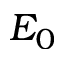Convert formula to latex. <formula><loc_0><loc_0><loc_500><loc_500>E _ { 0 }</formula> 